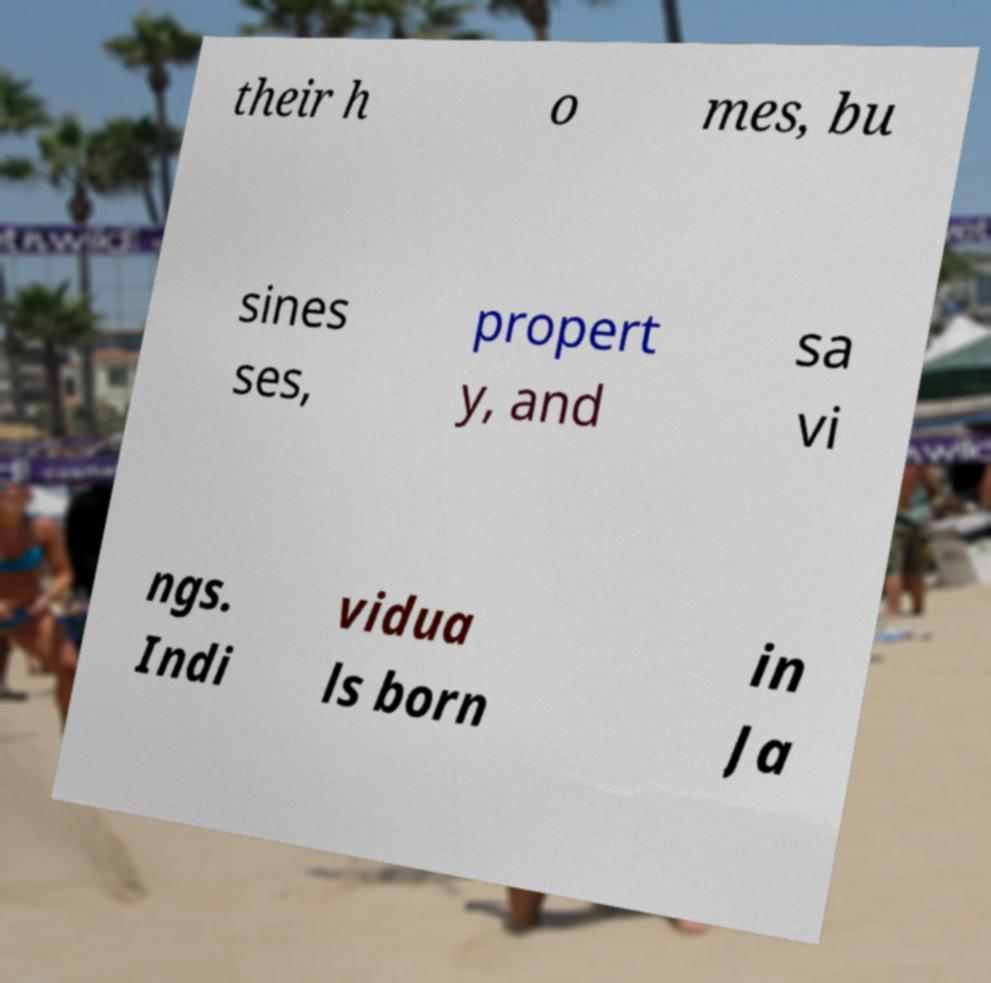Could you assist in decoding the text presented in this image and type it out clearly? their h o mes, bu sines ses, propert y, and sa vi ngs. Indi vidua ls born in Ja 